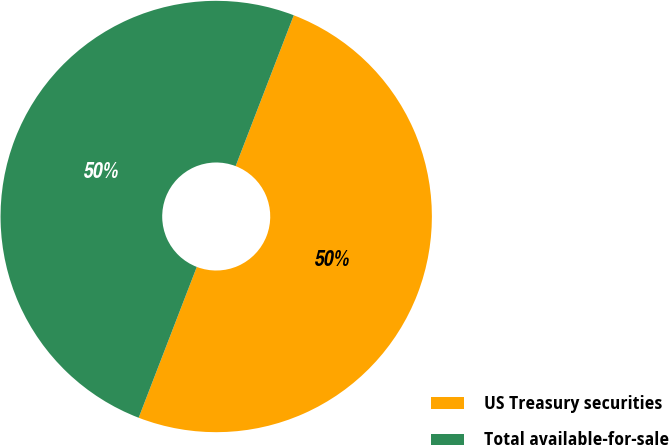<chart> <loc_0><loc_0><loc_500><loc_500><pie_chart><fcel>US Treasury securities<fcel>Total available-for-sale<nl><fcel>50.0%<fcel>50.0%<nl></chart> 